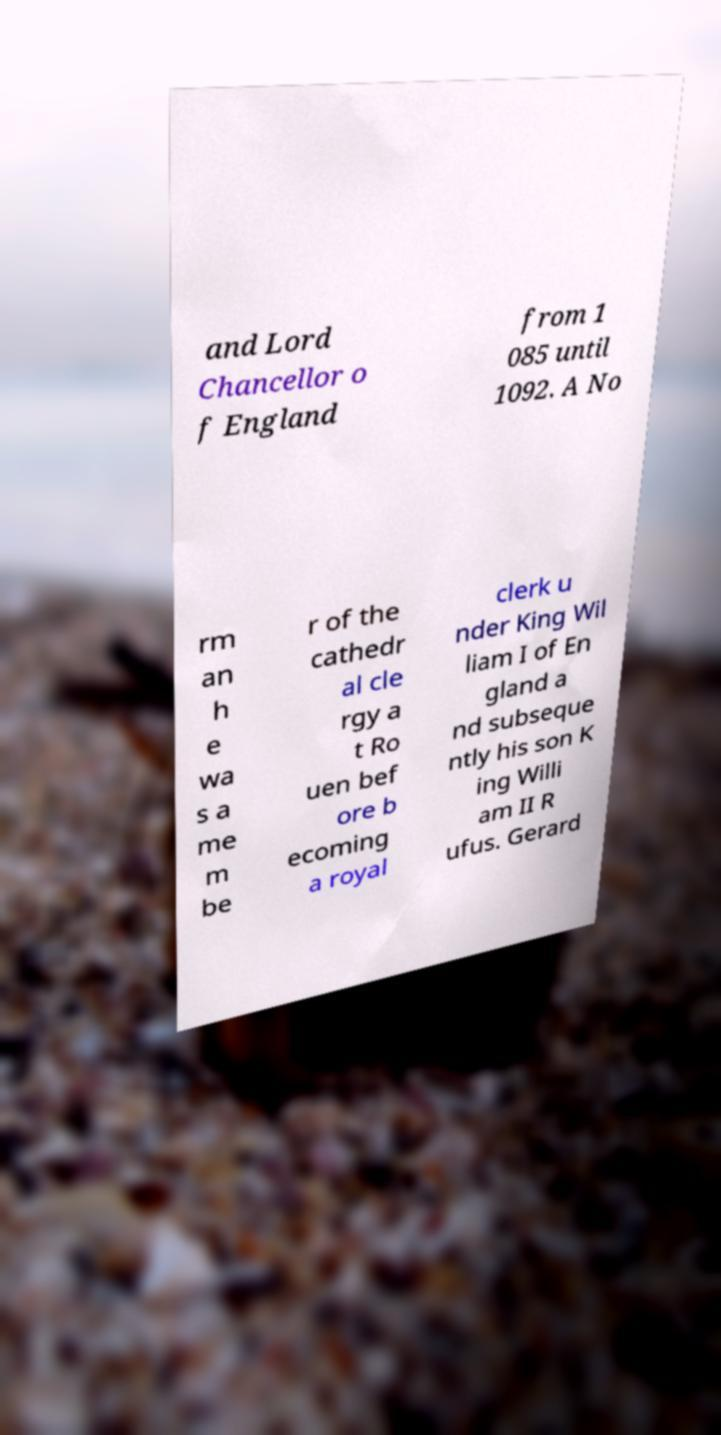There's text embedded in this image that I need extracted. Can you transcribe it verbatim? and Lord Chancellor o f England from 1 085 until 1092. A No rm an h e wa s a me m be r of the cathedr al cle rgy a t Ro uen bef ore b ecoming a royal clerk u nder King Wil liam I of En gland a nd subseque ntly his son K ing Willi am II R ufus. Gerard 